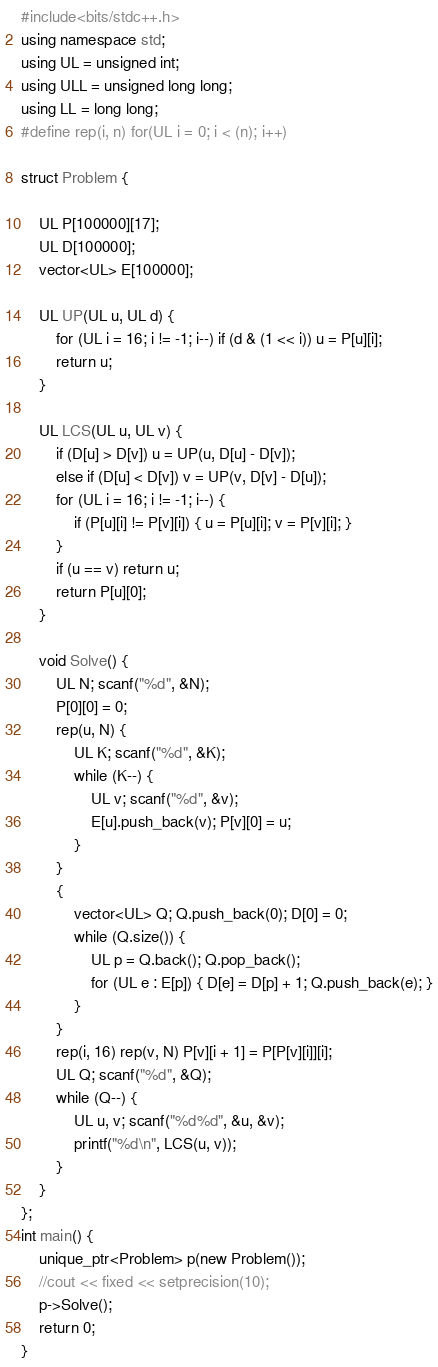<code> <loc_0><loc_0><loc_500><loc_500><_C++_>#include<bits/stdc++.h>
using namespace std;
using UL = unsigned int;
using ULL = unsigned long long;
using LL = long long;
#define rep(i, n) for(UL i = 0; i < (n); i++)

struct Problem {

    UL P[100000][17];
    UL D[100000];
    vector<UL> E[100000];

    UL UP(UL u, UL d) {
        for (UL i = 16; i != -1; i--) if (d & (1 << i)) u = P[u][i];
        return u;
    }

    UL LCS(UL u, UL v) {
        if (D[u] > D[v]) u = UP(u, D[u] - D[v]);
        else if (D[u] < D[v]) v = UP(v, D[v] - D[u]);
        for (UL i = 16; i != -1; i--) {
            if (P[u][i] != P[v][i]) { u = P[u][i]; v = P[v][i]; }
        }
        if (u == v) return u;
        return P[u][0];
    }

    void Solve() {
        UL N; scanf("%d", &N);
        P[0][0] = 0;
        rep(u, N) {
            UL K; scanf("%d", &K);
            while (K--) {
                UL v; scanf("%d", &v);
                E[u].push_back(v); P[v][0] = u;
            }
        }
        {
            vector<UL> Q; Q.push_back(0); D[0] = 0;
            while (Q.size()) {
                UL p = Q.back(); Q.pop_back();
                for (UL e : E[p]) { D[e] = D[p] + 1; Q.push_back(e); }
            }
        }
        rep(i, 16) rep(v, N) P[v][i + 1] = P[P[v][i]][i];
        UL Q; scanf("%d", &Q);
        while (Q--) {
            UL u, v; scanf("%d%d", &u, &v);
            printf("%d\n", LCS(u, v));
        }
    }
};
int main() {
    unique_ptr<Problem> p(new Problem());
    //cout << fixed << setprecision(10);
    p->Solve();
    return 0;
}


</code> 